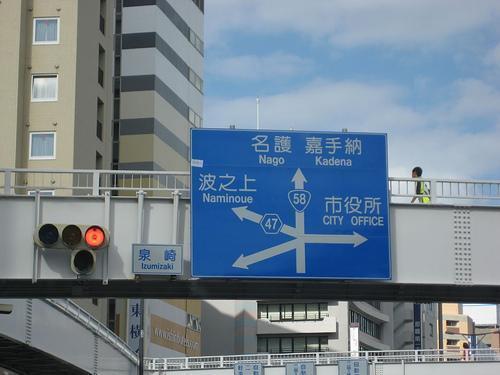How many traffic lights are there?
Give a very brief answer. 1. 